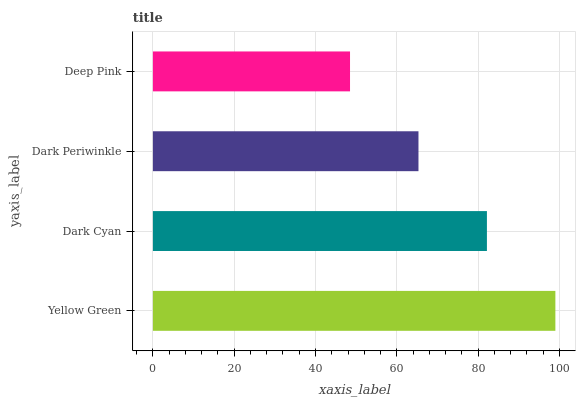Is Deep Pink the minimum?
Answer yes or no. Yes. Is Yellow Green the maximum?
Answer yes or no. Yes. Is Dark Cyan the minimum?
Answer yes or no. No. Is Dark Cyan the maximum?
Answer yes or no. No. Is Yellow Green greater than Dark Cyan?
Answer yes or no. Yes. Is Dark Cyan less than Yellow Green?
Answer yes or no. Yes. Is Dark Cyan greater than Yellow Green?
Answer yes or no. No. Is Yellow Green less than Dark Cyan?
Answer yes or no. No. Is Dark Cyan the high median?
Answer yes or no. Yes. Is Dark Periwinkle the low median?
Answer yes or no. Yes. Is Yellow Green the high median?
Answer yes or no. No. Is Deep Pink the low median?
Answer yes or no. No. 